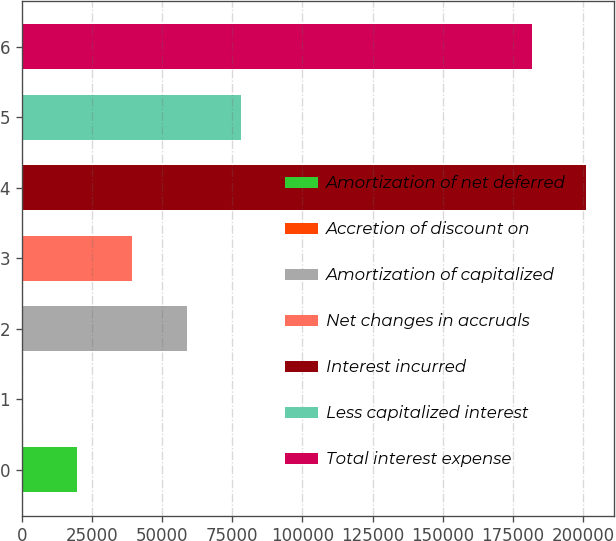<chart> <loc_0><loc_0><loc_500><loc_500><bar_chart><fcel>Amortization of net deferred<fcel>Accretion of discount on<fcel>Amortization of capitalized<fcel>Net changes in accruals<fcel>Interest incurred<fcel>Less capitalized interest<fcel>Total interest expense<nl><fcel>19780.1<fcel>315<fcel>58710.3<fcel>39245.2<fcel>201069<fcel>78175.4<fcel>181604<nl></chart> 